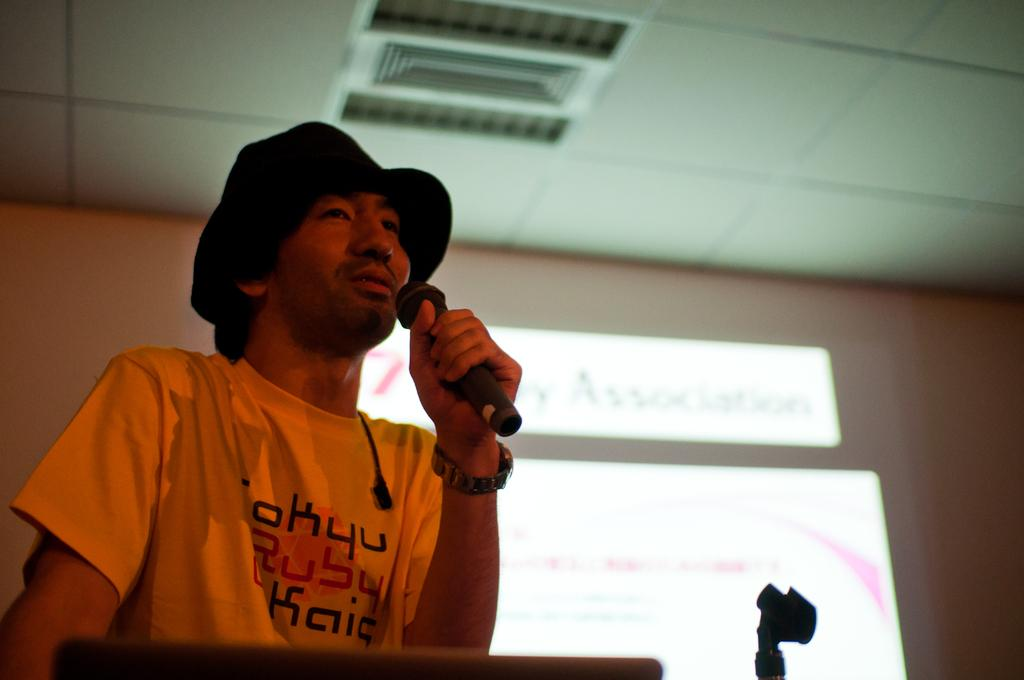What is the main subject of the image? There is a man in the image. What is the man doing in the image? The man is standing in the image. What object is the man holding in the image? The man is holding a microphone in the image. What is located behind the man in the image? There is a screen behind the man in the image. What can be seen at the top of the image? There is a roof visible at the top of the image. How many fingers is the man holding up in the image? There is no information about the man's fingers in the image, so we cannot determine how many he is holding up. Are there any sheep visible in the image? No, there are no sheep present in the image. 